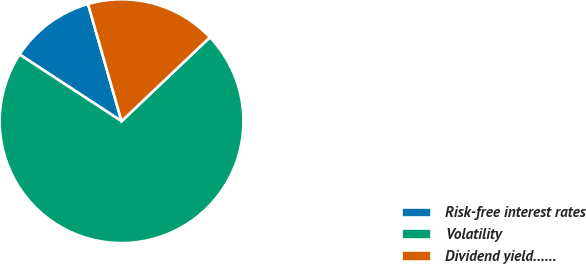<chart> <loc_0><loc_0><loc_500><loc_500><pie_chart><fcel>Risk-free interest rates<fcel>Volatility<fcel>Dividend yield……<nl><fcel>11.35%<fcel>71.31%<fcel>17.34%<nl></chart> 